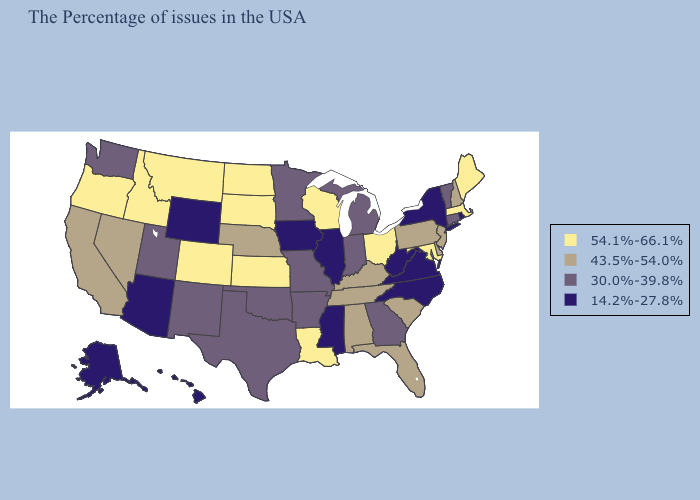Name the states that have a value in the range 54.1%-66.1%?
Quick response, please. Maine, Massachusetts, Maryland, Ohio, Wisconsin, Louisiana, Kansas, South Dakota, North Dakota, Colorado, Montana, Idaho, Oregon. Does New Jersey have a higher value than Massachusetts?
Write a very short answer. No. Name the states that have a value in the range 54.1%-66.1%?
Write a very short answer. Maine, Massachusetts, Maryland, Ohio, Wisconsin, Louisiana, Kansas, South Dakota, North Dakota, Colorado, Montana, Idaho, Oregon. What is the lowest value in the USA?
Short answer required. 14.2%-27.8%. Among the states that border Massachusetts , does Rhode Island have the lowest value?
Be succinct. Yes. Which states hav the highest value in the MidWest?
Keep it brief. Ohio, Wisconsin, Kansas, South Dakota, North Dakota. Among the states that border Colorado , does Utah have the lowest value?
Concise answer only. No. Name the states that have a value in the range 30.0%-39.8%?
Keep it brief. Vermont, Connecticut, Georgia, Michigan, Indiana, Missouri, Arkansas, Minnesota, Oklahoma, Texas, New Mexico, Utah, Washington. Does Maine have the highest value in the USA?
Write a very short answer. Yes. Name the states that have a value in the range 14.2%-27.8%?
Be succinct. Rhode Island, New York, Virginia, North Carolina, West Virginia, Illinois, Mississippi, Iowa, Wyoming, Arizona, Alaska, Hawaii. What is the highest value in the West ?
Concise answer only. 54.1%-66.1%. What is the highest value in the USA?
Quick response, please. 54.1%-66.1%. Does Louisiana have a higher value than Missouri?
Concise answer only. Yes. What is the lowest value in the MidWest?
Keep it brief. 14.2%-27.8%. What is the highest value in the West ?
Keep it brief. 54.1%-66.1%. 